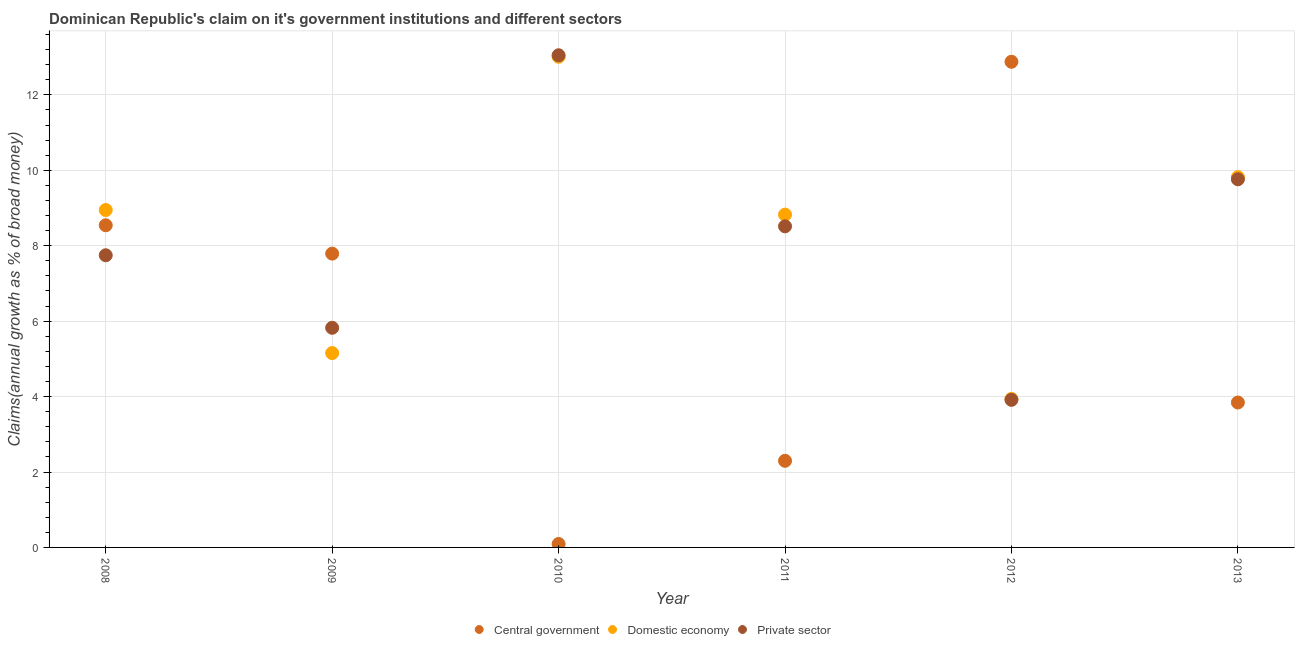How many different coloured dotlines are there?
Make the answer very short. 3. Is the number of dotlines equal to the number of legend labels?
Your response must be concise. Yes. What is the percentage of claim on the private sector in 2013?
Give a very brief answer. 9.76. Across all years, what is the maximum percentage of claim on the domestic economy?
Your answer should be very brief. 13.01. Across all years, what is the minimum percentage of claim on the central government?
Provide a short and direct response. 0.09. In which year was the percentage of claim on the private sector maximum?
Your response must be concise. 2010. In which year was the percentage of claim on the private sector minimum?
Provide a short and direct response. 2012. What is the total percentage of claim on the private sector in the graph?
Provide a short and direct response. 48.81. What is the difference between the percentage of claim on the domestic economy in 2010 and that in 2013?
Provide a succinct answer. 3.19. What is the difference between the percentage of claim on the central government in 2010 and the percentage of claim on the private sector in 2012?
Keep it short and to the point. -3.82. What is the average percentage of claim on the central government per year?
Give a very brief answer. 5.91. In the year 2011, what is the difference between the percentage of claim on the domestic economy and percentage of claim on the private sector?
Provide a succinct answer. 0.31. What is the ratio of the percentage of claim on the central government in 2008 to that in 2013?
Give a very brief answer. 2.22. Is the difference between the percentage of claim on the private sector in 2009 and 2013 greater than the difference between the percentage of claim on the central government in 2009 and 2013?
Your answer should be very brief. No. What is the difference between the highest and the second highest percentage of claim on the domestic economy?
Keep it short and to the point. 3.19. What is the difference between the highest and the lowest percentage of claim on the private sector?
Make the answer very short. 9.14. Does the percentage of claim on the central government monotonically increase over the years?
Your answer should be compact. No. Is the percentage of claim on the central government strictly greater than the percentage of claim on the domestic economy over the years?
Provide a succinct answer. No. How many legend labels are there?
Provide a short and direct response. 3. What is the title of the graph?
Offer a very short reply. Dominican Republic's claim on it's government institutions and different sectors. What is the label or title of the Y-axis?
Keep it short and to the point. Claims(annual growth as % of broad money). What is the Claims(annual growth as % of broad money) in Central government in 2008?
Your answer should be very brief. 8.54. What is the Claims(annual growth as % of broad money) in Domestic economy in 2008?
Your response must be concise. 8.95. What is the Claims(annual growth as % of broad money) of Private sector in 2008?
Your answer should be compact. 7.75. What is the Claims(annual growth as % of broad money) of Central government in 2009?
Provide a succinct answer. 7.79. What is the Claims(annual growth as % of broad money) in Domestic economy in 2009?
Keep it short and to the point. 5.15. What is the Claims(annual growth as % of broad money) in Private sector in 2009?
Make the answer very short. 5.82. What is the Claims(annual growth as % of broad money) in Central government in 2010?
Your response must be concise. 0.09. What is the Claims(annual growth as % of broad money) in Domestic economy in 2010?
Offer a terse response. 13.01. What is the Claims(annual growth as % of broad money) of Private sector in 2010?
Ensure brevity in your answer.  13.05. What is the Claims(annual growth as % of broad money) of Central government in 2011?
Your response must be concise. 2.3. What is the Claims(annual growth as % of broad money) in Domestic economy in 2011?
Offer a very short reply. 8.83. What is the Claims(annual growth as % of broad money) in Private sector in 2011?
Give a very brief answer. 8.51. What is the Claims(annual growth as % of broad money) of Central government in 2012?
Your response must be concise. 12.88. What is the Claims(annual growth as % of broad money) of Domestic economy in 2012?
Offer a terse response. 3.94. What is the Claims(annual growth as % of broad money) of Private sector in 2012?
Your answer should be compact. 3.91. What is the Claims(annual growth as % of broad money) of Central government in 2013?
Provide a short and direct response. 3.84. What is the Claims(annual growth as % of broad money) of Domestic economy in 2013?
Keep it short and to the point. 9.82. What is the Claims(annual growth as % of broad money) in Private sector in 2013?
Make the answer very short. 9.76. Across all years, what is the maximum Claims(annual growth as % of broad money) in Central government?
Offer a terse response. 12.88. Across all years, what is the maximum Claims(annual growth as % of broad money) in Domestic economy?
Provide a succinct answer. 13.01. Across all years, what is the maximum Claims(annual growth as % of broad money) of Private sector?
Keep it short and to the point. 13.05. Across all years, what is the minimum Claims(annual growth as % of broad money) of Central government?
Make the answer very short. 0.09. Across all years, what is the minimum Claims(annual growth as % of broad money) of Domestic economy?
Your answer should be compact. 3.94. Across all years, what is the minimum Claims(annual growth as % of broad money) in Private sector?
Your response must be concise. 3.91. What is the total Claims(annual growth as % of broad money) of Central government in the graph?
Your response must be concise. 35.44. What is the total Claims(annual growth as % of broad money) in Domestic economy in the graph?
Your answer should be compact. 49.69. What is the total Claims(annual growth as % of broad money) of Private sector in the graph?
Keep it short and to the point. 48.81. What is the difference between the Claims(annual growth as % of broad money) of Central government in 2008 and that in 2009?
Offer a very short reply. 0.75. What is the difference between the Claims(annual growth as % of broad money) of Domestic economy in 2008 and that in 2009?
Your response must be concise. 3.79. What is the difference between the Claims(annual growth as % of broad money) in Private sector in 2008 and that in 2009?
Make the answer very short. 1.92. What is the difference between the Claims(annual growth as % of broad money) in Central government in 2008 and that in 2010?
Offer a terse response. 8.45. What is the difference between the Claims(annual growth as % of broad money) in Domestic economy in 2008 and that in 2010?
Your answer should be very brief. -4.06. What is the difference between the Claims(annual growth as % of broad money) in Private sector in 2008 and that in 2010?
Offer a very short reply. -5.3. What is the difference between the Claims(annual growth as % of broad money) in Central government in 2008 and that in 2011?
Keep it short and to the point. 6.25. What is the difference between the Claims(annual growth as % of broad money) in Domestic economy in 2008 and that in 2011?
Offer a very short reply. 0.12. What is the difference between the Claims(annual growth as % of broad money) in Private sector in 2008 and that in 2011?
Provide a succinct answer. -0.77. What is the difference between the Claims(annual growth as % of broad money) in Central government in 2008 and that in 2012?
Provide a short and direct response. -4.34. What is the difference between the Claims(annual growth as % of broad money) of Domestic economy in 2008 and that in 2012?
Provide a succinct answer. 5.01. What is the difference between the Claims(annual growth as % of broad money) in Private sector in 2008 and that in 2012?
Provide a succinct answer. 3.83. What is the difference between the Claims(annual growth as % of broad money) of Central government in 2008 and that in 2013?
Give a very brief answer. 4.7. What is the difference between the Claims(annual growth as % of broad money) in Domestic economy in 2008 and that in 2013?
Offer a very short reply. -0.87. What is the difference between the Claims(annual growth as % of broad money) of Private sector in 2008 and that in 2013?
Offer a very short reply. -2.01. What is the difference between the Claims(annual growth as % of broad money) in Central government in 2009 and that in 2010?
Keep it short and to the point. 7.7. What is the difference between the Claims(annual growth as % of broad money) in Domestic economy in 2009 and that in 2010?
Provide a succinct answer. -7.86. What is the difference between the Claims(annual growth as % of broad money) of Private sector in 2009 and that in 2010?
Your answer should be compact. -7.23. What is the difference between the Claims(annual growth as % of broad money) in Central government in 2009 and that in 2011?
Make the answer very short. 5.49. What is the difference between the Claims(annual growth as % of broad money) of Domestic economy in 2009 and that in 2011?
Provide a short and direct response. -3.67. What is the difference between the Claims(annual growth as % of broad money) of Private sector in 2009 and that in 2011?
Give a very brief answer. -2.69. What is the difference between the Claims(annual growth as % of broad money) of Central government in 2009 and that in 2012?
Keep it short and to the point. -5.09. What is the difference between the Claims(annual growth as % of broad money) of Domestic economy in 2009 and that in 2012?
Your response must be concise. 1.22. What is the difference between the Claims(annual growth as % of broad money) of Private sector in 2009 and that in 2012?
Your response must be concise. 1.91. What is the difference between the Claims(annual growth as % of broad money) of Central government in 2009 and that in 2013?
Provide a succinct answer. 3.95. What is the difference between the Claims(annual growth as % of broad money) in Domestic economy in 2009 and that in 2013?
Offer a terse response. -4.67. What is the difference between the Claims(annual growth as % of broad money) of Private sector in 2009 and that in 2013?
Offer a terse response. -3.94. What is the difference between the Claims(annual growth as % of broad money) of Central government in 2010 and that in 2011?
Provide a succinct answer. -2.21. What is the difference between the Claims(annual growth as % of broad money) in Domestic economy in 2010 and that in 2011?
Provide a short and direct response. 4.19. What is the difference between the Claims(annual growth as % of broad money) in Private sector in 2010 and that in 2011?
Keep it short and to the point. 4.54. What is the difference between the Claims(annual growth as % of broad money) of Central government in 2010 and that in 2012?
Your response must be concise. -12.79. What is the difference between the Claims(annual growth as % of broad money) of Domestic economy in 2010 and that in 2012?
Make the answer very short. 9.07. What is the difference between the Claims(annual growth as % of broad money) of Private sector in 2010 and that in 2012?
Keep it short and to the point. 9.14. What is the difference between the Claims(annual growth as % of broad money) in Central government in 2010 and that in 2013?
Provide a succinct answer. -3.75. What is the difference between the Claims(annual growth as % of broad money) in Domestic economy in 2010 and that in 2013?
Offer a very short reply. 3.19. What is the difference between the Claims(annual growth as % of broad money) in Private sector in 2010 and that in 2013?
Offer a very short reply. 3.29. What is the difference between the Claims(annual growth as % of broad money) in Central government in 2011 and that in 2012?
Provide a short and direct response. -10.58. What is the difference between the Claims(annual growth as % of broad money) in Domestic economy in 2011 and that in 2012?
Ensure brevity in your answer.  4.89. What is the difference between the Claims(annual growth as % of broad money) in Private sector in 2011 and that in 2012?
Offer a very short reply. 4.6. What is the difference between the Claims(annual growth as % of broad money) in Central government in 2011 and that in 2013?
Ensure brevity in your answer.  -1.55. What is the difference between the Claims(annual growth as % of broad money) of Domestic economy in 2011 and that in 2013?
Offer a terse response. -0.99. What is the difference between the Claims(annual growth as % of broad money) of Private sector in 2011 and that in 2013?
Your answer should be very brief. -1.25. What is the difference between the Claims(annual growth as % of broad money) in Central government in 2012 and that in 2013?
Give a very brief answer. 9.04. What is the difference between the Claims(annual growth as % of broad money) in Domestic economy in 2012 and that in 2013?
Your answer should be compact. -5.88. What is the difference between the Claims(annual growth as % of broad money) of Private sector in 2012 and that in 2013?
Give a very brief answer. -5.85. What is the difference between the Claims(annual growth as % of broad money) of Central government in 2008 and the Claims(annual growth as % of broad money) of Domestic economy in 2009?
Keep it short and to the point. 3.39. What is the difference between the Claims(annual growth as % of broad money) in Central government in 2008 and the Claims(annual growth as % of broad money) in Private sector in 2009?
Ensure brevity in your answer.  2.72. What is the difference between the Claims(annual growth as % of broad money) of Domestic economy in 2008 and the Claims(annual growth as % of broad money) of Private sector in 2009?
Your answer should be compact. 3.12. What is the difference between the Claims(annual growth as % of broad money) of Central government in 2008 and the Claims(annual growth as % of broad money) of Domestic economy in 2010?
Ensure brevity in your answer.  -4.47. What is the difference between the Claims(annual growth as % of broad money) of Central government in 2008 and the Claims(annual growth as % of broad money) of Private sector in 2010?
Offer a very short reply. -4.51. What is the difference between the Claims(annual growth as % of broad money) in Domestic economy in 2008 and the Claims(annual growth as % of broad money) in Private sector in 2010?
Offer a terse response. -4.1. What is the difference between the Claims(annual growth as % of broad money) of Central government in 2008 and the Claims(annual growth as % of broad money) of Domestic economy in 2011?
Your answer should be compact. -0.28. What is the difference between the Claims(annual growth as % of broad money) of Central government in 2008 and the Claims(annual growth as % of broad money) of Private sector in 2011?
Keep it short and to the point. 0.03. What is the difference between the Claims(annual growth as % of broad money) of Domestic economy in 2008 and the Claims(annual growth as % of broad money) of Private sector in 2011?
Provide a short and direct response. 0.43. What is the difference between the Claims(annual growth as % of broad money) of Central government in 2008 and the Claims(annual growth as % of broad money) of Domestic economy in 2012?
Your answer should be very brief. 4.61. What is the difference between the Claims(annual growth as % of broad money) of Central government in 2008 and the Claims(annual growth as % of broad money) of Private sector in 2012?
Your response must be concise. 4.63. What is the difference between the Claims(annual growth as % of broad money) of Domestic economy in 2008 and the Claims(annual growth as % of broad money) of Private sector in 2012?
Make the answer very short. 5.03. What is the difference between the Claims(annual growth as % of broad money) of Central government in 2008 and the Claims(annual growth as % of broad money) of Domestic economy in 2013?
Your answer should be compact. -1.28. What is the difference between the Claims(annual growth as % of broad money) in Central government in 2008 and the Claims(annual growth as % of broad money) in Private sector in 2013?
Provide a succinct answer. -1.22. What is the difference between the Claims(annual growth as % of broad money) in Domestic economy in 2008 and the Claims(annual growth as % of broad money) in Private sector in 2013?
Give a very brief answer. -0.81. What is the difference between the Claims(annual growth as % of broad money) of Central government in 2009 and the Claims(annual growth as % of broad money) of Domestic economy in 2010?
Offer a terse response. -5.22. What is the difference between the Claims(annual growth as % of broad money) of Central government in 2009 and the Claims(annual growth as % of broad money) of Private sector in 2010?
Provide a short and direct response. -5.26. What is the difference between the Claims(annual growth as % of broad money) of Domestic economy in 2009 and the Claims(annual growth as % of broad money) of Private sector in 2010?
Offer a very short reply. -7.9. What is the difference between the Claims(annual growth as % of broad money) of Central government in 2009 and the Claims(annual growth as % of broad money) of Domestic economy in 2011?
Keep it short and to the point. -1.03. What is the difference between the Claims(annual growth as % of broad money) in Central government in 2009 and the Claims(annual growth as % of broad money) in Private sector in 2011?
Offer a terse response. -0.72. What is the difference between the Claims(annual growth as % of broad money) of Domestic economy in 2009 and the Claims(annual growth as % of broad money) of Private sector in 2011?
Provide a short and direct response. -3.36. What is the difference between the Claims(annual growth as % of broad money) of Central government in 2009 and the Claims(annual growth as % of broad money) of Domestic economy in 2012?
Ensure brevity in your answer.  3.85. What is the difference between the Claims(annual growth as % of broad money) in Central government in 2009 and the Claims(annual growth as % of broad money) in Private sector in 2012?
Provide a succinct answer. 3.88. What is the difference between the Claims(annual growth as % of broad money) of Domestic economy in 2009 and the Claims(annual growth as % of broad money) of Private sector in 2012?
Keep it short and to the point. 1.24. What is the difference between the Claims(annual growth as % of broad money) of Central government in 2009 and the Claims(annual growth as % of broad money) of Domestic economy in 2013?
Your answer should be compact. -2.03. What is the difference between the Claims(annual growth as % of broad money) of Central government in 2009 and the Claims(annual growth as % of broad money) of Private sector in 2013?
Provide a short and direct response. -1.97. What is the difference between the Claims(annual growth as % of broad money) in Domestic economy in 2009 and the Claims(annual growth as % of broad money) in Private sector in 2013?
Your response must be concise. -4.61. What is the difference between the Claims(annual growth as % of broad money) of Central government in 2010 and the Claims(annual growth as % of broad money) of Domestic economy in 2011?
Your response must be concise. -8.73. What is the difference between the Claims(annual growth as % of broad money) in Central government in 2010 and the Claims(annual growth as % of broad money) in Private sector in 2011?
Offer a very short reply. -8.42. What is the difference between the Claims(annual growth as % of broad money) in Domestic economy in 2010 and the Claims(annual growth as % of broad money) in Private sector in 2011?
Offer a very short reply. 4.5. What is the difference between the Claims(annual growth as % of broad money) of Central government in 2010 and the Claims(annual growth as % of broad money) of Domestic economy in 2012?
Provide a succinct answer. -3.85. What is the difference between the Claims(annual growth as % of broad money) of Central government in 2010 and the Claims(annual growth as % of broad money) of Private sector in 2012?
Ensure brevity in your answer.  -3.82. What is the difference between the Claims(annual growth as % of broad money) of Domestic economy in 2010 and the Claims(annual growth as % of broad money) of Private sector in 2012?
Offer a terse response. 9.1. What is the difference between the Claims(annual growth as % of broad money) in Central government in 2010 and the Claims(annual growth as % of broad money) in Domestic economy in 2013?
Your response must be concise. -9.73. What is the difference between the Claims(annual growth as % of broad money) in Central government in 2010 and the Claims(annual growth as % of broad money) in Private sector in 2013?
Provide a short and direct response. -9.67. What is the difference between the Claims(annual growth as % of broad money) of Domestic economy in 2010 and the Claims(annual growth as % of broad money) of Private sector in 2013?
Offer a terse response. 3.25. What is the difference between the Claims(annual growth as % of broad money) in Central government in 2011 and the Claims(annual growth as % of broad money) in Domestic economy in 2012?
Your response must be concise. -1.64. What is the difference between the Claims(annual growth as % of broad money) in Central government in 2011 and the Claims(annual growth as % of broad money) in Private sector in 2012?
Give a very brief answer. -1.62. What is the difference between the Claims(annual growth as % of broad money) in Domestic economy in 2011 and the Claims(annual growth as % of broad money) in Private sector in 2012?
Ensure brevity in your answer.  4.91. What is the difference between the Claims(annual growth as % of broad money) in Central government in 2011 and the Claims(annual growth as % of broad money) in Domestic economy in 2013?
Offer a very short reply. -7.52. What is the difference between the Claims(annual growth as % of broad money) in Central government in 2011 and the Claims(annual growth as % of broad money) in Private sector in 2013?
Give a very brief answer. -7.47. What is the difference between the Claims(annual growth as % of broad money) of Domestic economy in 2011 and the Claims(annual growth as % of broad money) of Private sector in 2013?
Keep it short and to the point. -0.94. What is the difference between the Claims(annual growth as % of broad money) of Central government in 2012 and the Claims(annual growth as % of broad money) of Domestic economy in 2013?
Make the answer very short. 3.06. What is the difference between the Claims(annual growth as % of broad money) in Central government in 2012 and the Claims(annual growth as % of broad money) in Private sector in 2013?
Give a very brief answer. 3.12. What is the difference between the Claims(annual growth as % of broad money) in Domestic economy in 2012 and the Claims(annual growth as % of broad money) in Private sector in 2013?
Offer a terse response. -5.82. What is the average Claims(annual growth as % of broad money) of Central government per year?
Offer a very short reply. 5.91. What is the average Claims(annual growth as % of broad money) in Domestic economy per year?
Offer a terse response. 8.28. What is the average Claims(annual growth as % of broad money) of Private sector per year?
Your answer should be compact. 8.14. In the year 2008, what is the difference between the Claims(annual growth as % of broad money) in Central government and Claims(annual growth as % of broad money) in Domestic economy?
Make the answer very short. -0.4. In the year 2008, what is the difference between the Claims(annual growth as % of broad money) of Central government and Claims(annual growth as % of broad money) of Private sector?
Your answer should be very brief. 0.8. In the year 2008, what is the difference between the Claims(annual growth as % of broad money) in Domestic economy and Claims(annual growth as % of broad money) in Private sector?
Your answer should be very brief. 1.2. In the year 2009, what is the difference between the Claims(annual growth as % of broad money) in Central government and Claims(annual growth as % of broad money) in Domestic economy?
Make the answer very short. 2.64. In the year 2009, what is the difference between the Claims(annual growth as % of broad money) of Central government and Claims(annual growth as % of broad money) of Private sector?
Give a very brief answer. 1.97. In the year 2009, what is the difference between the Claims(annual growth as % of broad money) in Domestic economy and Claims(annual growth as % of broad money) in Private sector?
Your response must be concise. -0.67. In the year 2010, what is the difference between the Claims(annual growth as % of broad money) of Central government and Claims(annual growth as % of broad money) of Domestic economy?
Your answer should be very brief. -12.92. In the year 2010, what is the difference between the Claims(annual growth as % of broad money) of Central government and Claims(annual growth as % of broad money) of Private sector?
Offer a terse response. -12.96. In the year 2010, what is the difference between the Claims(annual growth as % of broad money) of Domestic economy and Claims(annual growth as % of broad money) of Private sector?
Your answer should be compact. -0.04. In the year 2011, what is the difference between the Claims(annual growth as % of broad money) of Central government and Claims(annual growth as % of broad money) of Domestic economy?
Your answer should be very brief. -6.53. In the year 2011, what is the difference between the Claims(annual growth as % of broad money) of Central government and Claims(annual growth as % of broad money) of Private sector?
Your response must be concise. -6.22. In the year 2011, what is the difference between the Claims(annual growth as % of broad money) in Domestic economy and Claims(annual growth as % of broad money) in Private sector?
Provide a succinct answer. 0.31. In the year 2012, what is the difference between the Claims(annual growth as % of broad money) in Central government and Claims(annual growth as % of broad money) in Domestic economy?
Provide a short and direct response. 8.94. In the year 2012, what is the difference between the Claims(annual growth as % of broad money) in Central government and Claims(annual growth as % of broad money) in Private sector?
Make the answer very short. 8.96. In the year 2012, what is the difference between the Claims(annual growth as % of broad money) of Domestic economy and Claims(annual growth as % of broad money) of Private sector?
Provide a succinct answer. 0.02. In the year 2013, what is the difference between the Claims(annual growth as % of broad money) in Central government and Claims(annual growth as % of broad money) in Domestic economy?
Offer a very short reply. -5.98. In the year 2013, what is the difference between the Claims(annual growth as % of broad money) in Central government and Claims(annual growth as % of broad money) in Private sector?
Offer a terse response. -5.92. In the year 2013, what is the difference between the Claims(annual growth as % of broad money) of Domestic economy and Claims(annual growth as % of broad money) of Private sector?
Provide a succinct answer. 0.06. What is the ratio of the Claims(annual growth as % of broad money) in Central government in 2008 to that in 2009?
Ensure brevity in your answer.  1.1. What is the ratio of the Claims(annual growth as % of broad money) in Domestic economy in 2008 to that in 2009?
Offer a terse response. 1.74. What is the ratio of the Claims(annual growth as % of broad money) of Private sector in 2008 to that in 2009?
Offer a terse response. 1.33. What is the ratio of the Claims(annual growth as % of broad money) in Central government in 2008 to that in 2010?
Your answer should be compact. 93.51. What is the ratio of the Claims(annual growth as % of broad money) of Domestic economy in 2008 to that in 2010?
Provide a short and direct response. 0.69. What is the ratio of the Claims(annual growth as % of broad money) of Private sector in 2008 to that in 2010?
Make the answer very short. 0.59. What is the ratio of the Claims(annual growth as % of broad money) in Central government in 2008 to that in 2011?
Offer a very short reply. 3.72. What is the ratio of the Claims(annual growth as % of broad money) of Domestic economy in 2008 to that in 2011?
Keep it short and to the point. 1.01. What is the ratio of the Claims(annual growth as % of broad money) in Private sector in 2008 to that in 2011?
Keep it short and to the point. 0.91. What is the ratio of the Claims(annual growth as % of broad money) of Central government in 2008 to that in 2012?
Offer a terse response. 0.66. What is the ratio of the Claims(annual growth as % of broad money) in Domestic economy in 2008 to that in 2012?
Give a very brief answer. 2.27. What is the ratio of the Claims(annual growth as % of broad money) in Private sector in 2008 to that in 2012?
Offer a terse response. 1.98. What is the ratio of the Claims(annual growth as % of broad money) in Central government in 2008 to that in 2013?
Your response must be concise. 2.22. What is the ratio of the Claims(annual growth as % of broad money) of Domestic economy in 2008 to that in 2013?
Your answer should be very brief. 0.91. What is the ratio of the Claims(annual growth as % of broad money) of Private sector in 2008 to that in 2013?
Your answer should be compact. 0.79. What is the ratio of the Claims(annual growth as % of broad money) in Central government in 2009 to that in 2010?
Your response must be concise. 85.27. What is the ratio of the Claims(annual growth as % of broad money) in Domestic economy in 2009 to that in 2010?
Ensure brevity in your answer.  0.4. What is the ratio of the Claims(annual growth as % of broad money) in Private sector in 2009 to that in 2010?
Your answer should be compact. 0.45. What is the ratio of the Claims(annual growth as % of broad money) in Central government in 2009 to that in 2011?
Keep it short and to the point. 3.39. What is the ratio of the Claims(annual growth as % of broad money) in Domestic economy in 2009 to that in 2011?
Give a very brief answer. 0.58. What is the ratio of the Claims(annual growth as % of broad money) in Private sector in 2009 to that in 2011?
Your answer should be compact. 0.68. What is the ratio of the Claims(annual growth as % of broad money) in Central government in 2009 to that in 2012?
Your answer should be very brief. 0.6. What is the ratio of the Claims(annual growth as % of broad money) of Domestic economy in 2009 to that in 2012?
Your answer should be very brief. 1.31. What is the ratio of the Claims(annual growth as % of broad money) in Private sector in 2009 to that in 2012?
Provide a short and direct response. 1.49. What is the ratio of the Claims(annual growth as % of broad money) of Central government in 2009 to that in 2013?
Offer a terse response. 2.03. What is the ratio of the Claims(annual growth as % of broad money) in Domestic economy in 2009 to that in 2013?
Your answer should be compact. 0.52. What is the ratio of the Claims(annual growth as % of broad money) in Private sector in 2009 to that in 2013?
Make the answer very short. 0.6. What is the ratio of the Claims(annual growth as % of broad money) of Central government in 2010 to that in 2011?
Provide a short and direct response. 0.04. What is the ratio of the Claims(annual growth as % of broad money) of Domestic economy in 2010 to that in 2011?
Provide a short and direct response. 1.47. What is the ratio of the Claims(annual growth as % of broad money) of Private sector in 2010 to that in 2011?
Provide a succinct answer. 1.53. What is the ratio of the Claims(annual growth as % of broad money) of Central government in 2010 to that in 2012?
Offer a terse response. 0.01. What is the ratio of the Claims(annual growth as % of broad money) of Domestic economy in 2010 to that in 2012?
Your response must be concise. 3.3. What is the ratio of the Claims(annual growth as % of broad money) in Private sector in 2010 to that in 2012?
Offer a terse response. 3.34. What is the ratio of the Claims(annual growth as % of broad money) in Central government in 2010 to that in 2013?
Provide a succinct answer. 0.02. What is the ratio of the Claims(annual growth as % of broad money) of Domestic economy in 2010 to that in 2013?
Make the answer very short. 1.32. What is the ratio of the Claims(annual growth as % of broad money) of Private sector in 2010 to that in 2013?
Your response must be concise. 1.34. What is the ratio of the Claims(annual growth as % of broad money) in Central government in 2011 to that in 2012?
Your response must be concise. 0.18. What is the ratio of the Claims(annual growth as % of broad money) in Domestic economy in 2011 to that in 2012?
Keep it short and to the point. 2.24. What is the ratio of the Claims(annual growth as % of broad money) of Private sector in 2011 to that in 2012?
Give a very brief answer. 2.18. What is the ratio of the Claims(annual growth as % of broad money) in Central government in 2011 to that in 2013?
Make the answer very short. 0.6. What is the ratio of the Claims(annual growth as % of broad money) in Domestic economy in 2011 to that in 2013?
Offer a terse response. 0.9. What is the ratio of the Claims(annual growth as % of broad money) of Private sector in 2011 to that in 2013?
Provide a short and direct response. 0.87. What is the ratio of the Claims(annual growth as % of broad money) in Central government in 2012 to that in 2013?
Ensure brevity in your answer.  3.35. What is the ratio of the Claims(annual growth as % of broad money) of Domestic economy in 2012 to that in 2013?
Your answer should be compact. 0.4. What is the ratio of the Claims(annual growth as % of broad money) of Private sector in 2012 to that in 2013?
Ensure brevity in your answer.  0.4. What is the difference between the highest and the second highest Claims(annual growth as % of broad money) of Central government?
Provide a succinct answer. 4.34. What is the difference between the highest and the second highest Claims(annual growth as % of broad money) of Domestic economy?
Your answer should be very brief. 3.19. What is the difference between the highest and the second highest Claims(annual growth as % of broad money) in Private sector?
Keep it short and to the point. 3.29. What is the difference between the highest and the lowest Claims(annual growth as % of broad money) in Central government?
Ensure brevity in your answer.  12.79. What is the difference between the highest and the lowest Claims(annual growth as % of broad money) in Domestic economy?
Keep it short and to the point. 9.07. What is the difference between the highest and the lowest Claims(annual growth as % of broad money) in Private sector?
Provide a short and direct response. 9.14. 